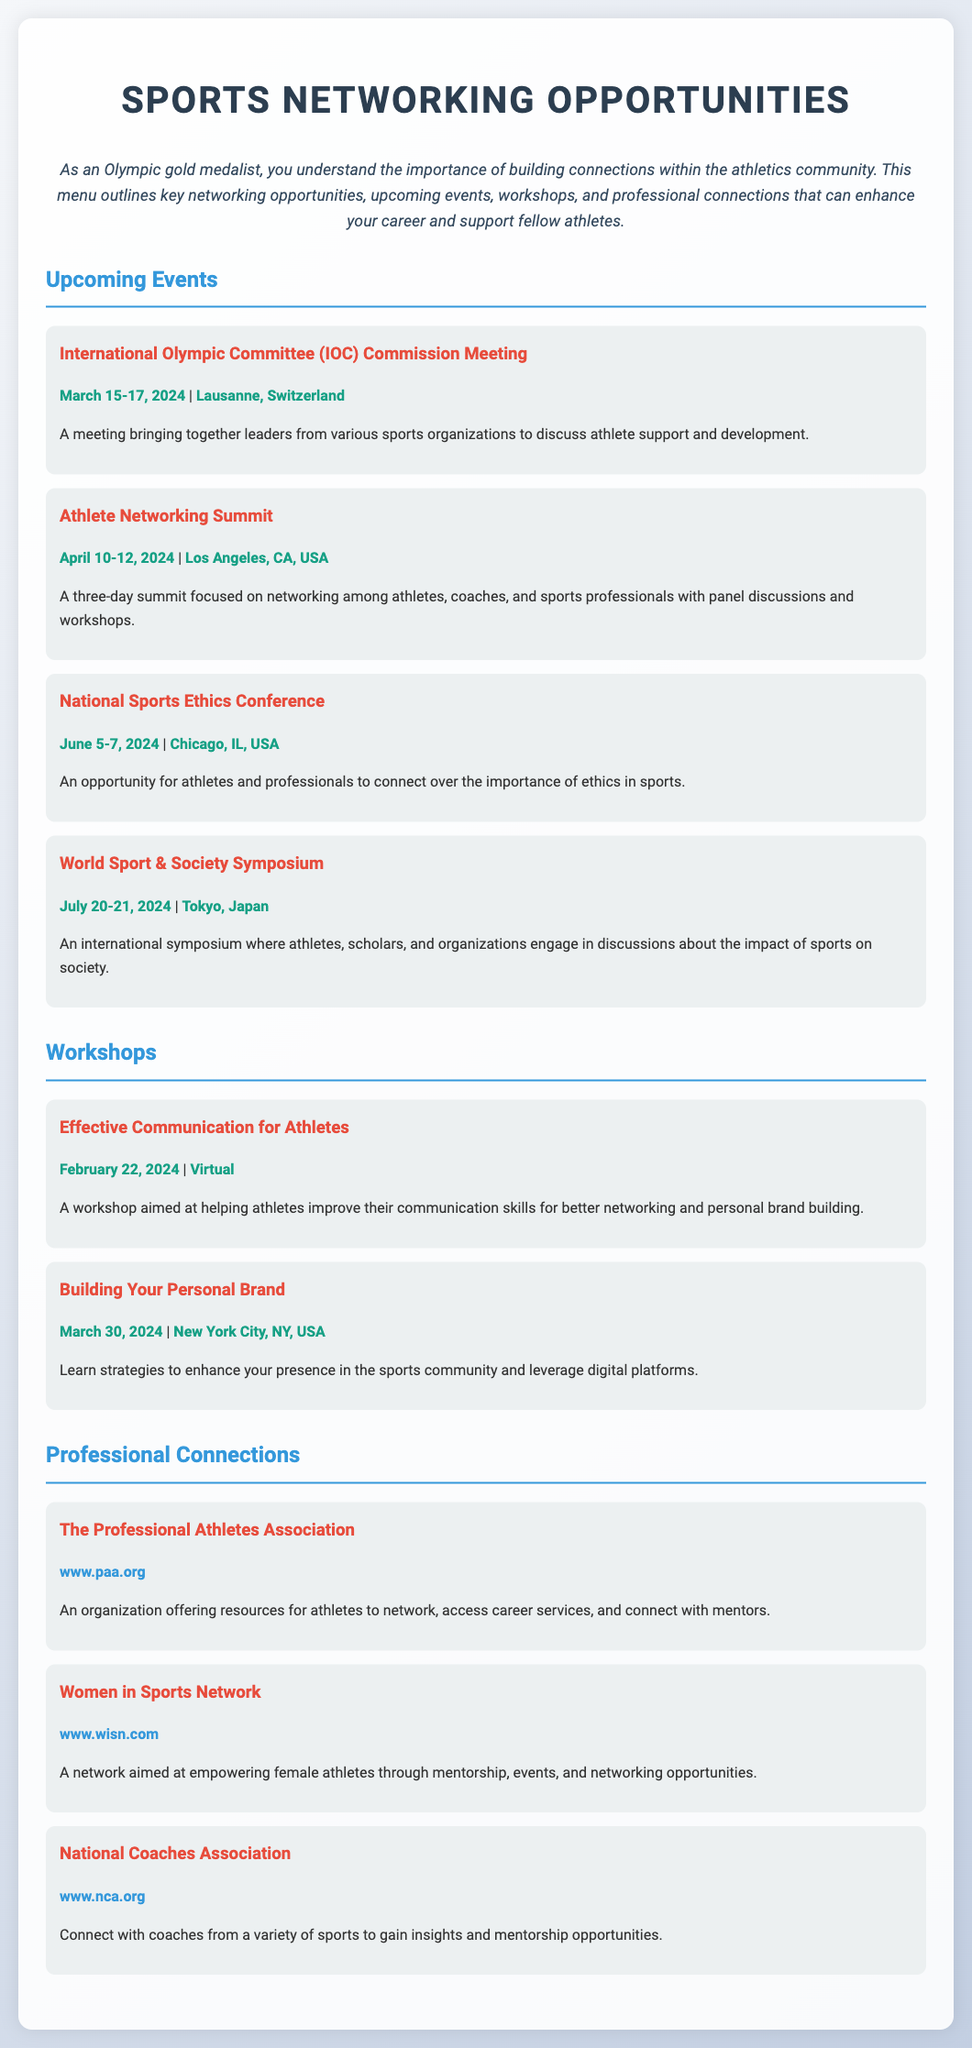What is the first event listed? The first event mentioned in the document is the International Olympic Committee Commission Meeting.
Answer: International Olympic Committee (IOC) Commission Meeting What is the date of the Athlete Networking Summit? The document lists the date for the Athlete Networking Summit as April 10-12, 2024.
Answer: April 10-12, 2024 Where is the National Sports Ethics Conference taking place? According to the document, the location of the National Sports Ethics Conference is Chicago, IL, USA.
Answer: Chicago, IL, USA What is the theme of the workshop scheduled for February 22, 2024? The workshop on February 22, 2024, focuses on improving communication skills for better networking.
Answer: Effective Communication for Athletes Which professional connection organization focuses on female athletes? The document indicates the Women in Sports Network is aimed at empowering female athletes.
Answer: Women in Sports Network How many days will the World Sport & Society Symposium last? The World Sport & Society Symposium is scheduled to last for two days, on July 20-21, 2024.
Answer: Two days What is the purpose of the Professional Athletes Association? The document states that it offers resources for athletes to network and access career services.
Answer: Networking and career services Which workshop teaches strategies to enhance digital presence? The document specifies that the workshop titled "Building Your Personal Brand" teaches strategies for leveraging digital platforms.
Answer: Building Your Personal Brand 